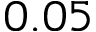<formula> <loc_0><loc_0><loc_500><loc_500>0 . 0 5</formula> 